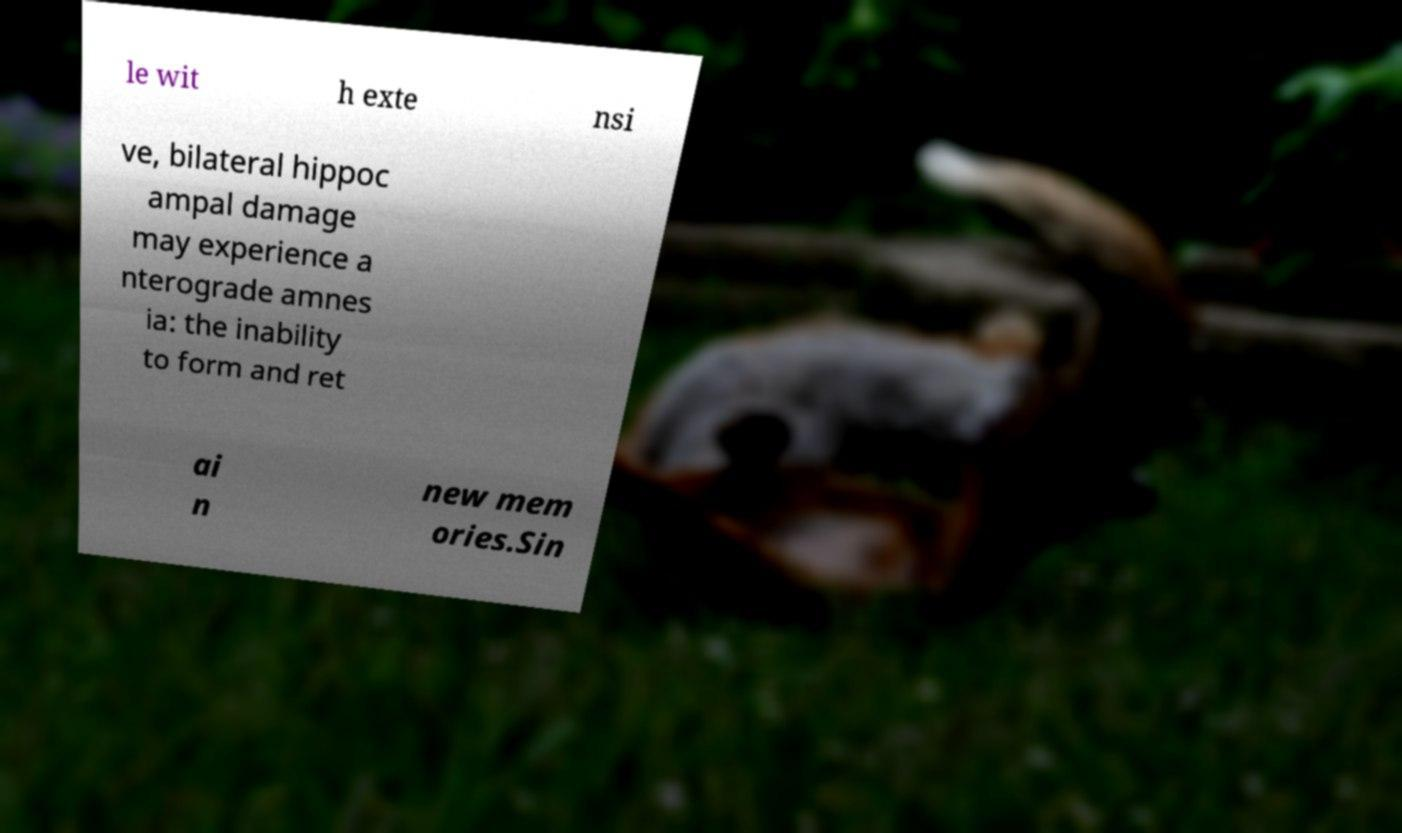Can you accurately transcribe the text from the provided image for me? le wit h exte nsi ve, bilateral hippoc ampal damage may experience a nterograde amnes ia: the inability to form and ret ai n new mem ories.Sin 